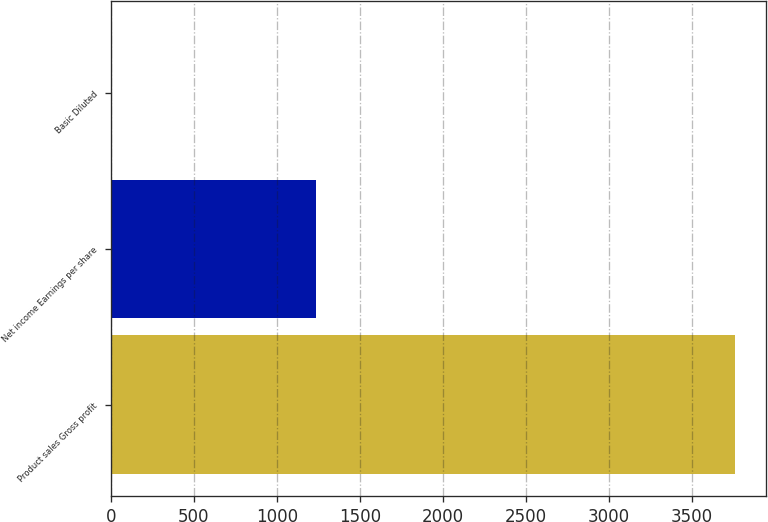Convert chart to OTSL. <chart><loc_0><loc_0><loc_500><loc_500><bar_chart><fcel>Product sales Gross profit<fcel>Net income Earnings per share<fcel>Basic Diluted<nl><fcel>3759<fcel>1236<fcel>1.28<nl></chart> 